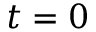Convert formula to latex. <formula><loc_0><loc_0><loc_500><loc_500>t = 0</formula> 